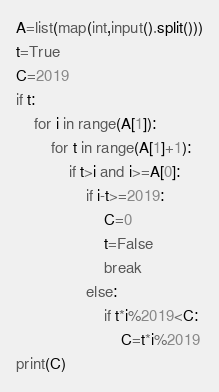Convert code to text. <code><loc_0><loc_0><loc_500><loc_500><_Python_>A=list(map(int,input().split()))
t=True
C=2019
if t:
    for i in range(A[1]):
        for t in range(A[1]+1):
            if t>i and i>=A[0]:
                if i-t>=2019:
                    C=0
                    t=False
                    break
                else:
                    if t*i%2019<C:
                        C=t*i%2019
print(C)</code> 